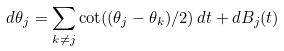<formula> <loc_0><loc_0><loc_500><loc_500>d \theta _ { j } = \sum _ { k \not = j } \cot ( ( \theta _ { j } - \theta _ { k } ) / 2 ) \, d t + d B _ { j } ( t )</formula> 